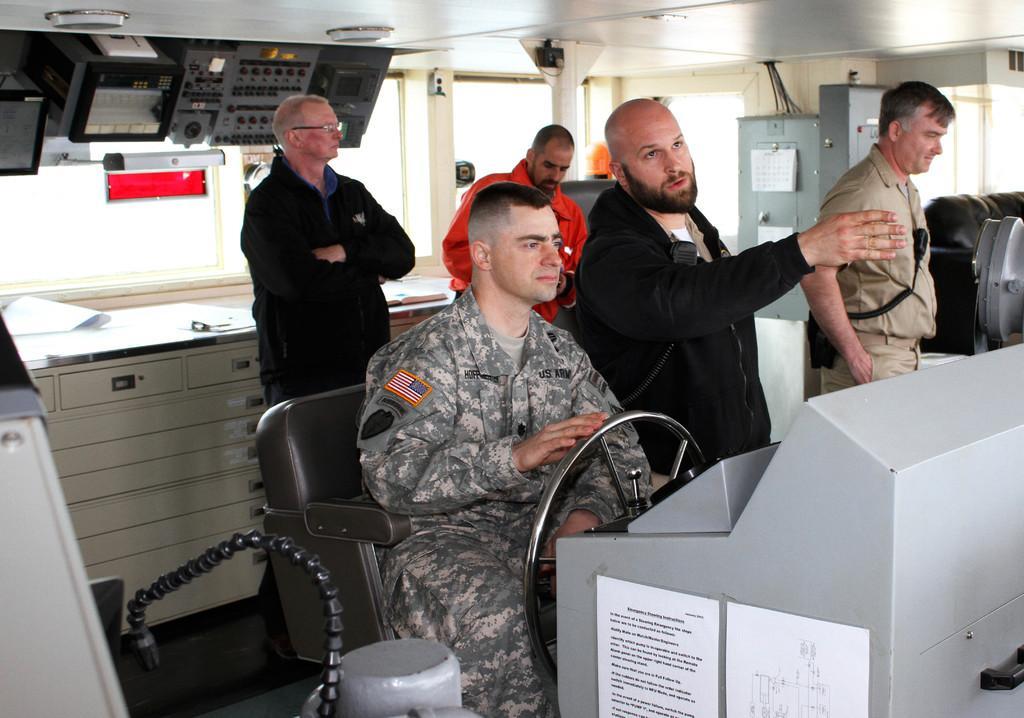Describe this image in one or two sentences. In this picture there is a soldier who is holding the steering. Beside there is a man wearing black coat showing the directions. In the background we can see two persons are standing. Above we can see the some switches boards. 